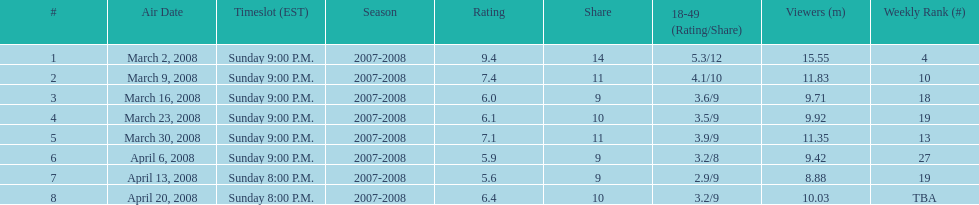Parse the table in full. {'header': ['#', 'Air Date', 'Timeslot (EST)', 'Season', 'Rating', 'Share', '18-49 (Rating/Share)', 'Viewers (m)', 'Weekly Rank (#)'], 'rows': [['1', 'March 2, 2008', 'Sunday 9:00 P.M.', '2007-2008', '9.4', '14', '5.3/12', '15.55', '4'], ['2', 'March 9, 2008', 'Sunday 9:00 P.M.', '2007-2008', '7.4', '11', '4.1/10', '11.83', '10'], ['3', 'March 16, 2008', 'Sunday 9:00 P.M.', '2007-2008', '6.0', '9', '3.6/9', '9.71', '18'], ['4', 'March 23, 2008', 'Sunday 9:00 P.M.', '2007-2008', '6.1', '10', '3.5/9', '9.92', '19'], ['5', 'March 30, 2008', 'Sunday 9:00 P.M.', '2007-2008', '7.1', '11', '3.9/9', '11.35', '13'], ['6', 'April 6, 2008', 'Sunday 9:00 P.M.', '2007-2008', '5.9', '9', '3.2/8', '9.42', '27'], ['7', 'April 13, 2008', 'Sunday 8:00 P.M.', '2007-2008', '5.6', '9', '2.9/9', '8.88', '19'], ['8', 'April 20, 2008', 'Sunday 8:00 P.M.', '2007-2008', '6.4', '10', '3.2/9', '10.03', 'TBA']]} How many programs attracted an audience of over 10 million viewers? 4. 